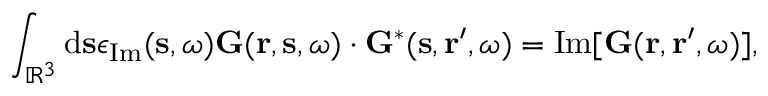<formula> <loc_0><loc_0><loc_500><loc_500>\int _ { \mathbb { R } ^ { 3 } } d s \epsilon _ { I m } ( s , \omega ) G ( r , s , \omega ) \cdot G ^ { * } ( s , r ^ { \prime } , \omega ) = I m [ G ( r , r ^ { \prime } , \omega ) ] ,</formula> 